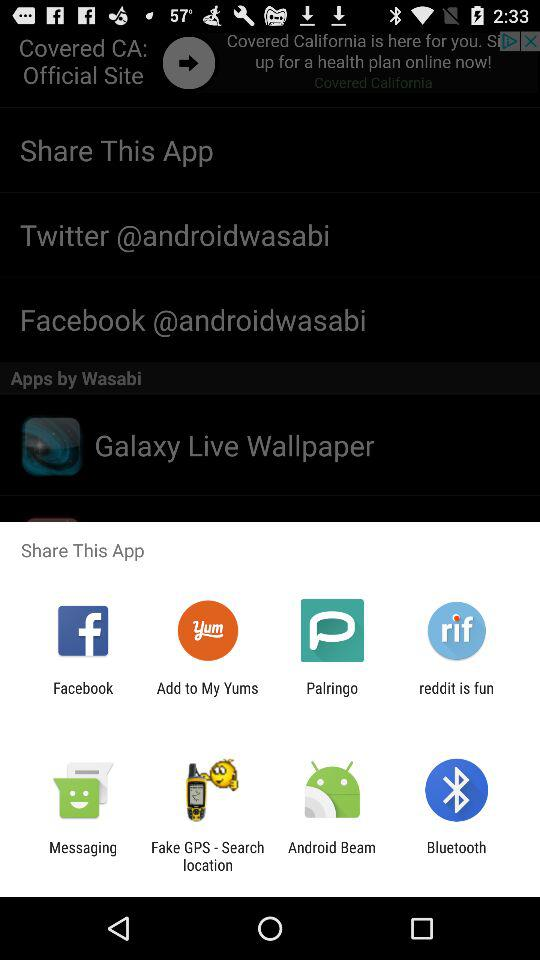What options are given to share? The sharing options are "Facebook", "Add to My Yums", "Palringo", "reddit is fun", "Messaging", "Fake GPS - Search location", "Android Beam" and "Bluetooth". 